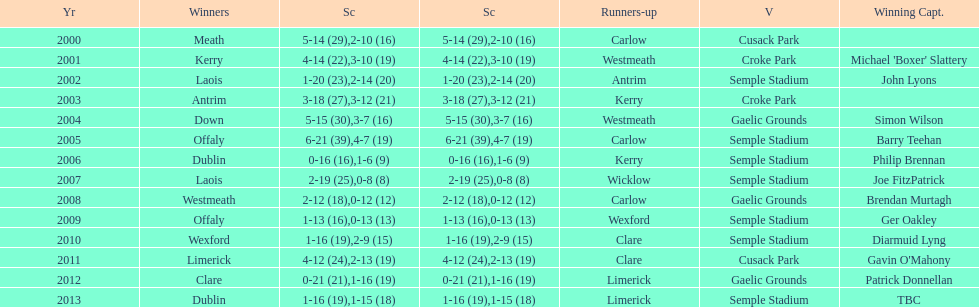What is the difference in the scores in 2000? 13. 